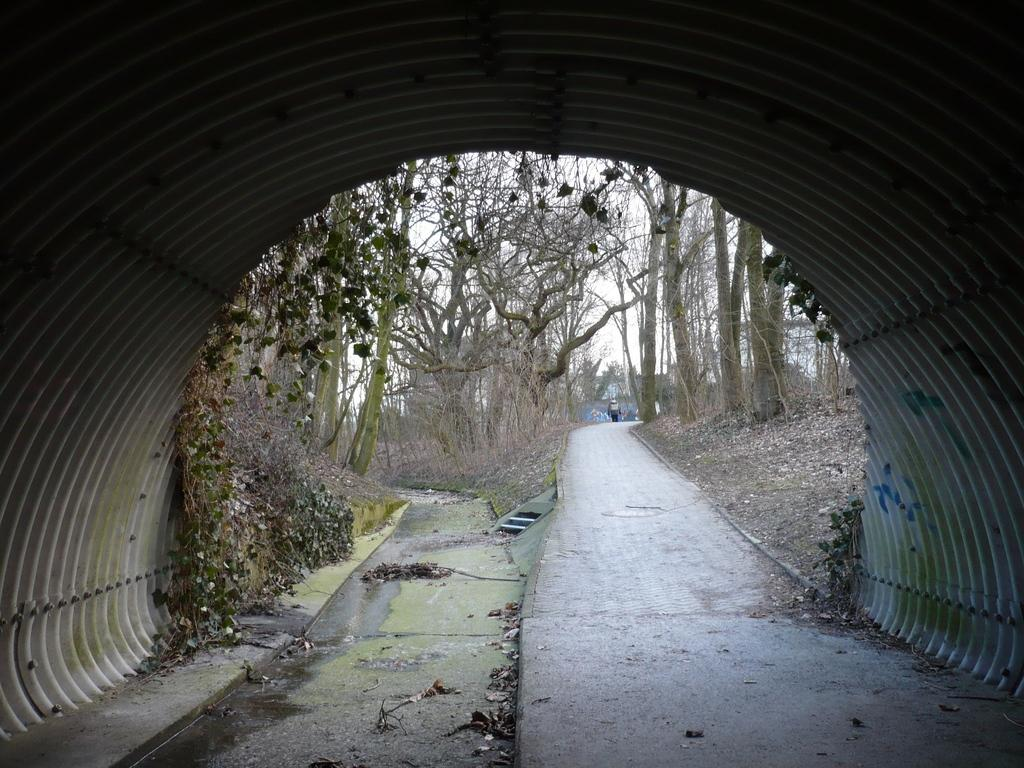What type of structure can be seen in the image? There is a tunnel in the image. What else is present in the image besides the tunnel? There is a road, water, trees, dry leaves, a person moving, and the sky visible in the image. Can you describe the road in the image? The road is visible in the image, and there is a person moving on it. What type of vegetation is present in the image? Trees are present in the image. What can be seen in the background of the image? The sky is visible in the background of the image. Where is the pump located in the image? There is no pump present in the image. Can you tell me how many zebras are visible in the image? There are no zebras present in the image. 